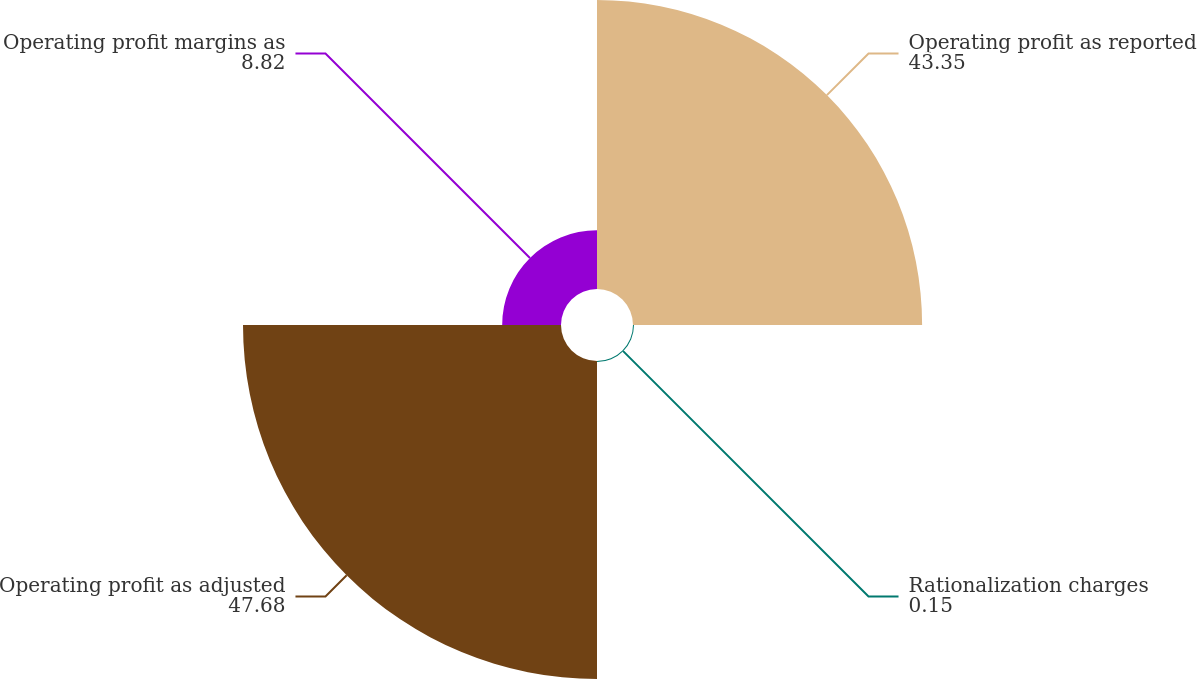<chart> <loc_0><loc_0><loc_500><loc_500><pie_chart><fcel>Operating profit as reported<fcel>Rationalization charges<fcel>Operating profit as adjusted<fcel>Operating profit margins as<nl><fcel>43.35%<fcel>0.15%<fcel>47.68%<fcel>8.82%<nl></chart> 